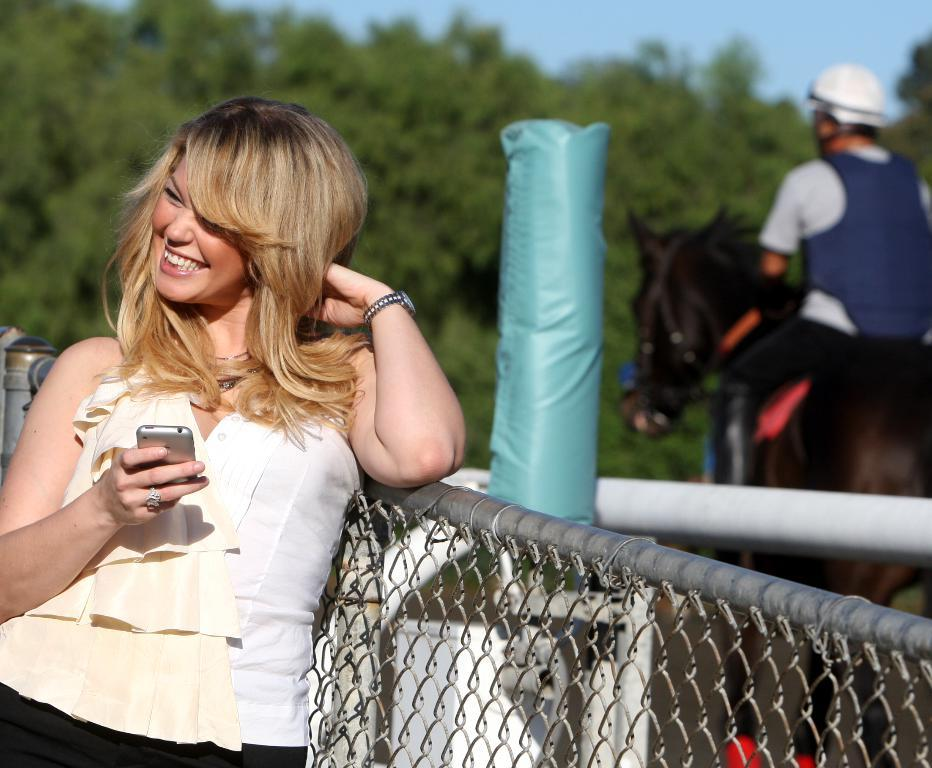Who is the main subject in the image? There is a lady in the image in the image. What is the lady wearing? The lady is wearing a white top. What is the lady holding in her hand? The lady is holding a phone in her right hand. Where is the lady standing? The lady is standing near a grill. What can be seen in the background of the image? There are trees visible in the background, and there is a man on a horse in the background. What type of rice is being cooked on the grill in the image? There is no rice present in the image, and the grill is not being used for cooking. 